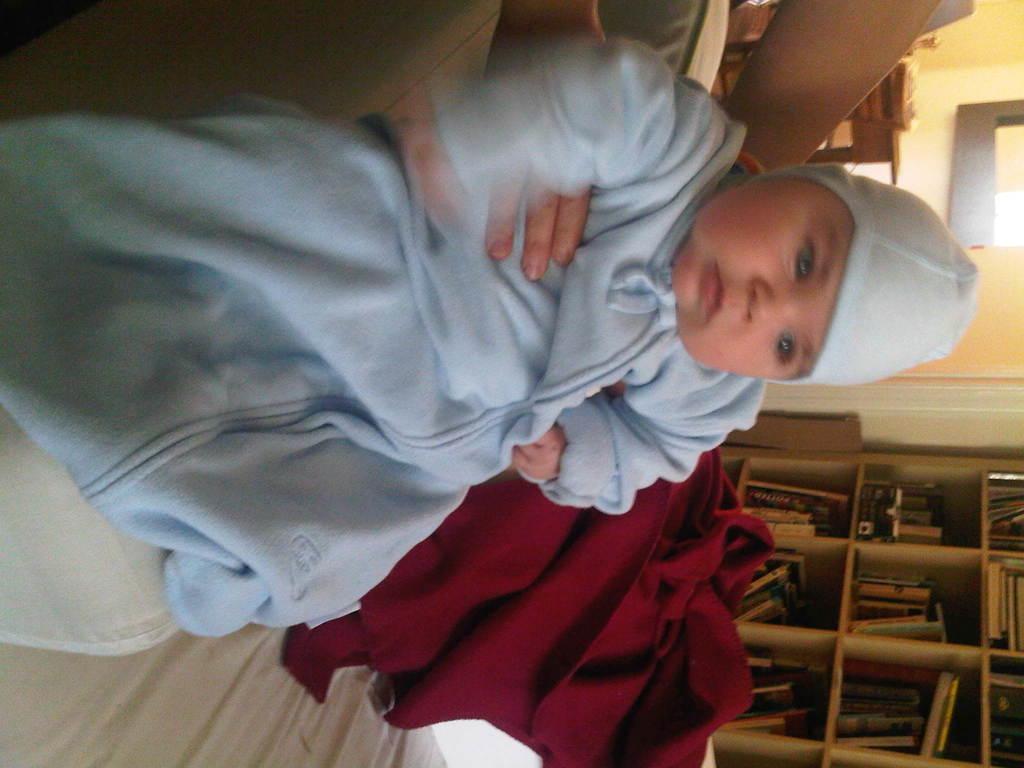Can you describe this image briefly? In this image in the front there is a kid and there are hands visible of the person. In the background there is a cloth which is red in colour and there are shelves and inside the shelfs there are books. There is a table and there is a chair. 